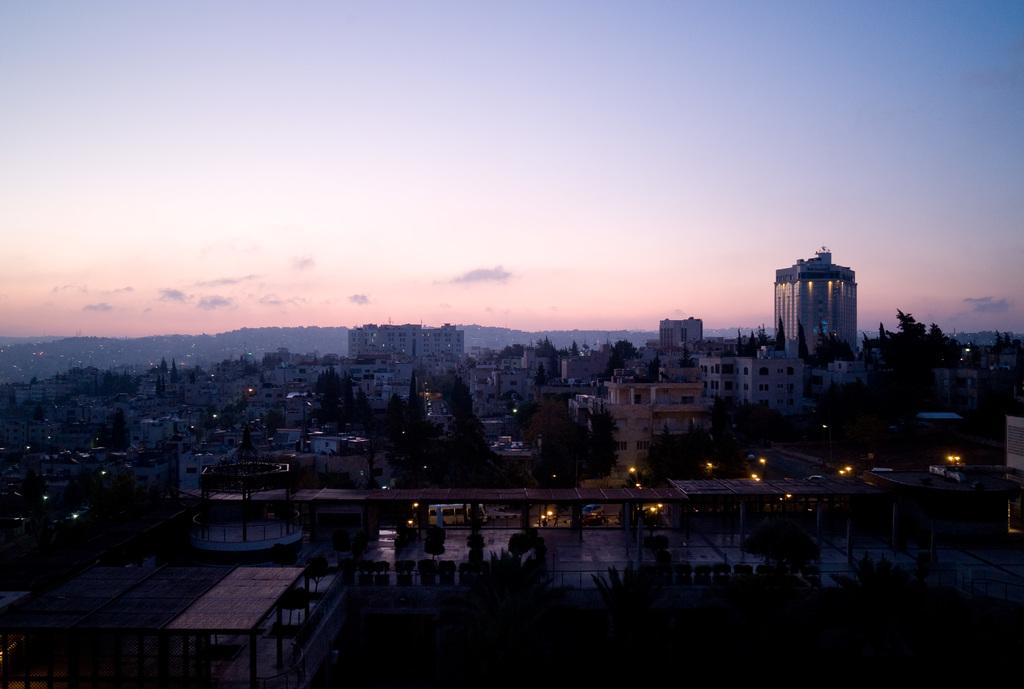What type of vegetation can be seen in the image? There are trees in the image. What structures are present in the image? There are buildings in the image. What can be seen illuminating the scene in the image? There are lights in the image. What is visible in the background of the image? The sky is visible behind the buildings. Are there any horses reading profit reports in the image? There are no horses or profit reports present in the image. What type of reading material is being used by the trees in the image? There are no trees or reading material present in the image. 